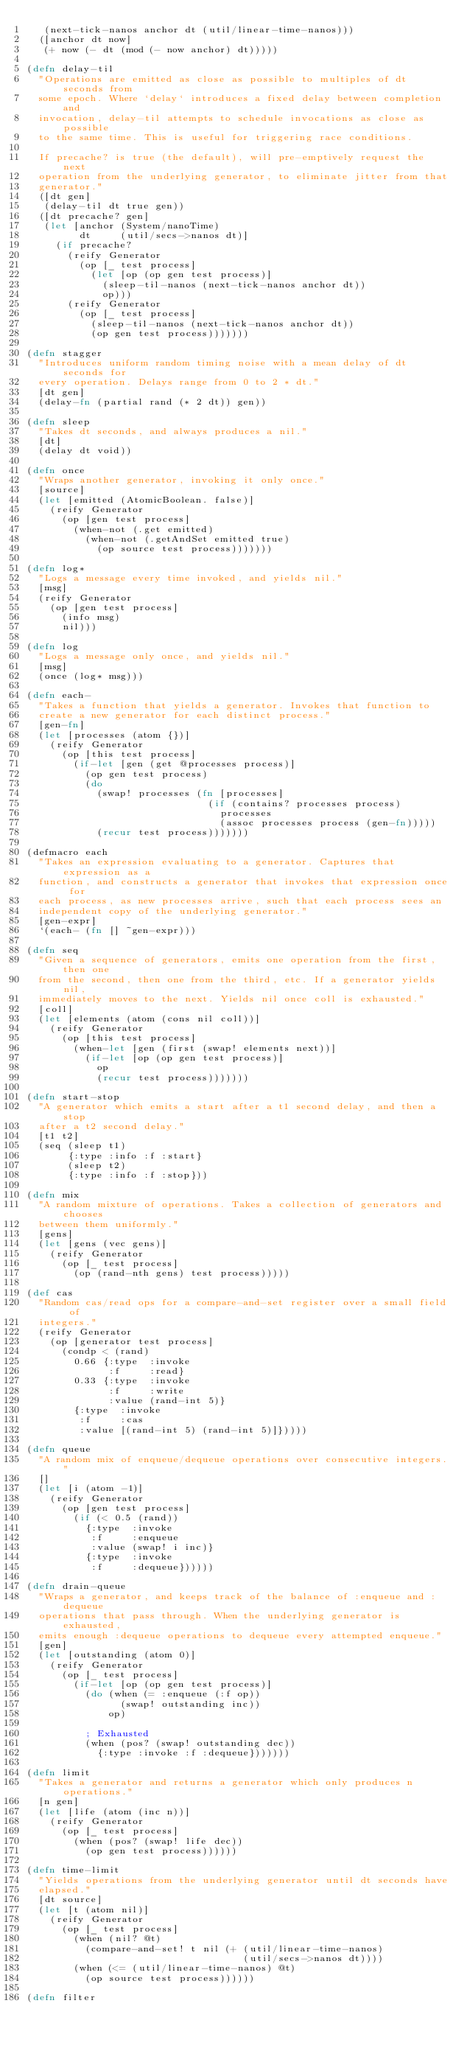Convert code to text. <code><loc_0><loc_0><loc_500><loc_500><_Clojure_>   (next-tick-nanos anchor dt (util/linear-time-nanos)))
  ([anchor dt now]
   (+ now (- dt (mod (- now anchor) dt)))))

(defn delay-til
  "Operations are emitted as close as possible to multiples of dt seconds from
  some epoch. Where `delay` introduces a fixed delay between completion and
  invocation, delay-til attempts to schedule invocations as close as possible
  to the same time. This is useful for triggering race conditions.

  If precache? is true (the default), will pre-emptively request the next
  operation from the underlying generator, to eliminate jitter from that
  generator."
  ([dt gen]
   (delay-til dt true gen))
  ([dt precache? gen]
   (let [anchor (System/nanoTime)
         dt     (util/secs->nanos dt)]
     (if precache?
       (reify Generator
         (op [_ test process]
           (let [op (op gen test process)]
             (sleep-til-nanos (next-tick-nanos anchor dt))
             op)))
       (reify Generator
         (op [_ test process]
           (sleep-til-nanos (next-tick-nanos anchor dt))
           (op gen test process)))))))

(defn stagger
  "Introduces uniform random timing noise with a mean delay of dt seconds for
  every operation. Delays range from 0 to 2 * dt."
  [dt gen]
  (delay-fn (partial rand (* 2 dt)) gen))

(defn sleep
  "Takes dt seconds, and always produces a nil."
  [dt]
  (delay dt void))

(defn once
  "Wraps another generator, invoking it only once."
  [source]
  (let [emitted (AtomicBoolean. false)]
    (reify Generator
      (op [gen test process]
        (when-not (.get emitted)
          (when-not (.getAndSet emitted true)
            (op source test process)))))))

(defn log*
  "Logs a message every time invoked, and yields nil."
  [msg]
  (reify Generator
    (op [gen test process]
      (info msg)
      nil)))

(defn log
  "Logs a message only once, and yields nil."
  [msg]
  (once (log* msg)))

(defn each-
  "Takes a function that yields a generator. Invokes that function to
  create a new generator for each distinct process."
  [gen-fn]
  (let [processes (atom {})]
    (reify Generator
      (op [this test process]
        (if-let [gen (get @processes process)]
          (op gen test process)
          (do
            (swap! processes (fn [processes]
                               (if (contains? processes process)
                                 processes
                                 (assoc processes process (gen-fn)))))
            (recur test process)))))))

(defmacro each
  "Takes an expression evaluating to a generator. Captures that expression as a
  function, and constructs a generator that invokes that expression once for
  each process, as new processes arrive, such that each process sees an
  independent copy of the underlying generator."
  [gen-expr]
  `(each- (fn [] ~gen-expr)))

(defn seq
  "Given a sequence of generators, emits one operation from the first, then one
  from the second, then one from the third, etc. If a generator yields nil,
  immediately moves to the next. Yields nil once coll is exhausted."
  [coll]
  (let [elements (atom (cons nil coll))]
    (reify Generator
      (op [this test process]
        (when-let [gen (first (swap! elements next))]
          (if-let [op (op gen test process)]
            op
            (recur test process)))))))

(defn start-stop
  "A generator which emits a start after a t1 second delay, and then a stop
  after a t2 second delay."
  [t1 t2]
  (seq (sleep t1)
       {:type :info :f :start}
       (sleep t2)
       {:type :info :f :stop}))

(defn mix
  "A random mixture of operations. Takes a collection of generators and chooses
  between them uniformly."
  [gens]
  (let [gens (vec gens)]
    (reify Generator
      (op [_ test process]
        (op (rand-nth gens) test process)))))

(def cas
  "Random cas/read ops for a compare-and-set register over a small field of
  integers."
  (reify Generator
    (op [generator test process]
      (condp < (rand)
        0.66 {:type  :invoke
              :f     :read}
        0.33 {:type  :invoke
              :f     :write
              :value (rand-int 5)}
        {:type  :invoke
         :f     :cas
         :value [(rand-int 5) (rand-int 5)]}))))

(defn queue
  "A random mix of enqueue/dequeue operations over consecutive integers."
  []
  (let [i (atom -1)]
    (reify Generator
      (op [gen test process]
        (if (< 0.5 (rand))
          {:type  :invoke
           :f     :enqueue
           :value (swap! i inc)}
          {:type  :invoke
           :f     :dequeue})))))

(defn drain-queue
  "Wraps a generator, and keeps track of the balance of :enqueue and :dequeue
  operations that pass through. When the underlying generator is exhausted,
  emits enough :dequeue operations to dequeue every attempted enqueue."
  [gen]
  (let [outstanding (atom 0)]
    (reify Generator
      (op [_ test process]
        (if-let [op (op gen test process)]
          (do (when (= :enqueue (:f op))
                (swap! outstanding inc))
              op)

          ; Exhausted
          (when (pos? (swap! outstanding dec))
            {:type :invoke :f :dequeue}))))))

(defn limit
  "Takes a generator and returns a generator which only produces n operations."
  [n gen]
  (let [life (atom (inc n))]
    (reify Generator
      (op [_ test process]
        (when (pos? (swap! life dec))
          (op gen test process))))))

(defn time-limit
  "Yields operations from the underlying generator until dt seconds have
  elapsed."
  [dt source]
  (let [t (atom nil)]
    (reify Generator
      (op [_ test process]
        (when (nil? @t)
          (compare-and-set! t nil (+ (util/linear-time-nanos)
                                     (util/secs->nanos dt))))
        (when (<= (util/linear-time-nanos) @t)
          (op source test process))))))

(defn filter</code> 